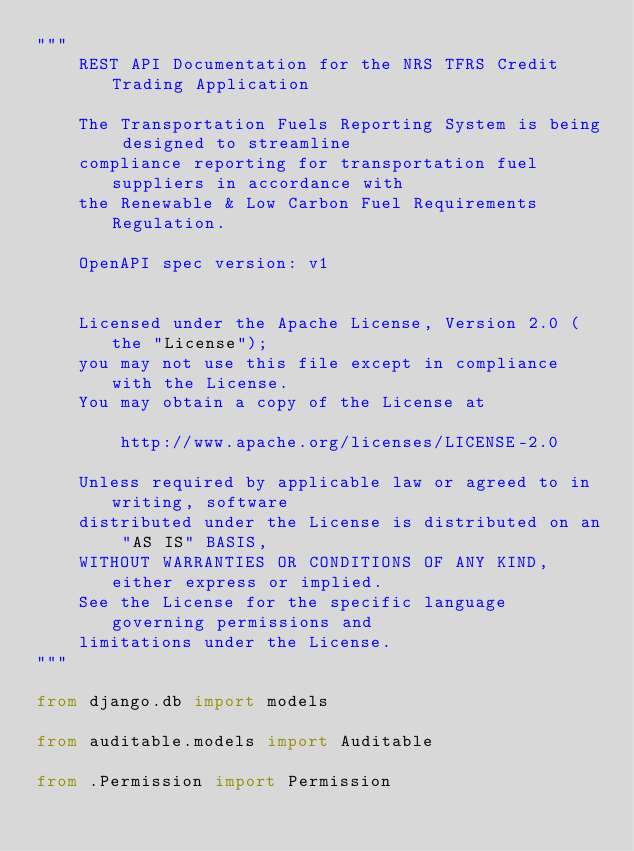Convert code to text. <code><loc_0><loc_0><loc_500><loc_500><_Python_>"""
    REST API Documentation for the NRS TFRS Credit Trading Application

    The Transportation Fuels Reporting System is being designed to streamline
    compliance reporting for transportation fuel suppliers in accordance with
    the Renewable & Low Carbon Fuel Requirements Regulation.

    OpenAPI spec version: v1


    Licensed under the Apache License, Version 2.0 (the "License");
    you may not use this file except in compliance with the License.
    You may obtain a copy of the License at

        http://www.apache.org/licenses/LICENSE-2.0

    Unless required by applicable law or agreed to in writing, software
    distributed under the License is distributed on an "AS IS" BASIS,
    WITHOUT WARRANTIES OR CONDITIONS OF ANY KIND, either express or implied.
    See the License for the specific language governing permissions and
    limitations under the License.
"""

from django.db import models

from auditable.models import Auditable

from .Permission import Permission

</code> 